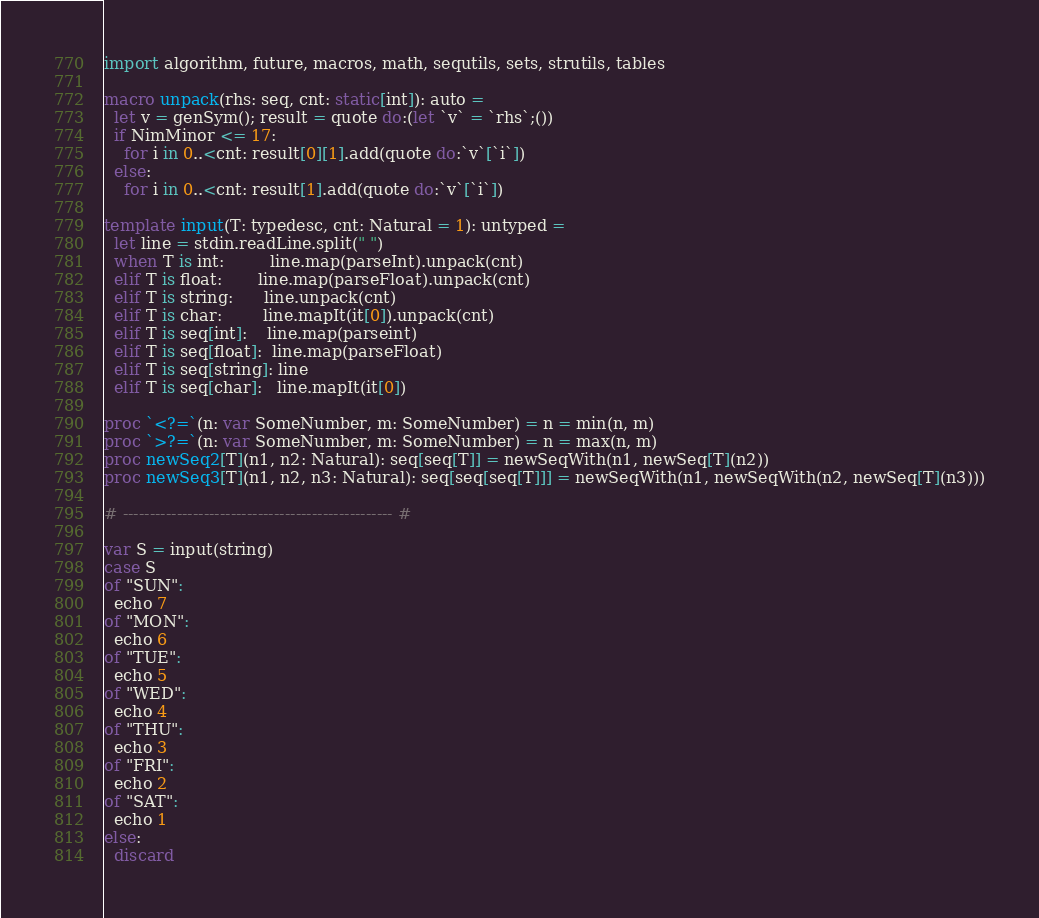<code> <loc_0><loc_0><loc_500><loc_500><_Nim_>import algorithm, future, macros, math, sequtils, sets, strutils, tables

macro unpack(rhs: seq, cnt: static[int]): auto =
  let v = genSym(); result = quote do:(let `v` = `rhs`;())
  if NimMinor <= 17:
    for i in 0..<cnt: result[0][1].add(quote do:`v`[`i`])
  else:
    for i in 0..<cnt: result[1].add(quote do:`v`[`i`])

template input(T: typedesc, cnt: Natural = 1): untyped =
  let line = stdin.readLine.split(" ")
  when T is int:         line.map(parseInt).unpack(cnt)
  elif T is float:       line.map(parseFloat).unpack(cnt)
  elif T is string:      line.unpack(cnt)
  elif T is char:        line.mapIt(it[0]).unpack(cnt)
  elif T is seq[int]:    line.map(parseint)
  elif T is seq[float]:  line.map(parseFloat)
  elif T is seq[string]: line
  elif T is seq[char]:   line.mapIt(it[0])

proc `<?=`(n: var SomeNumber, m: SomeNumber) = n = min(n, m)
proc `>?=`(n: var SomeNumber, m: SomeNumber) = n = max(n, m)
proc newSeq2[T](n1, n2: Natural): seq[seq[T]] = newSeqWith(n1, newSeq[T](n2))
proc newSeq3[T](n1, n2, n3: Natural): seq[seq[seq[T]]] = newSeqWith(n1, newSeqWith(n2, newSeq[T](n3)))

# -------------------------------------------------- #

var S = input(string)
case S
of "SUN":
  echo 7
of "MON":
  echo 6
of "TUE":
  echo 5
of "WED":
  echo 4
of "THU":
  echo 3
of "FRI":
  echo 2
of "SAT":
  echo 1
else:
  discard</code> 